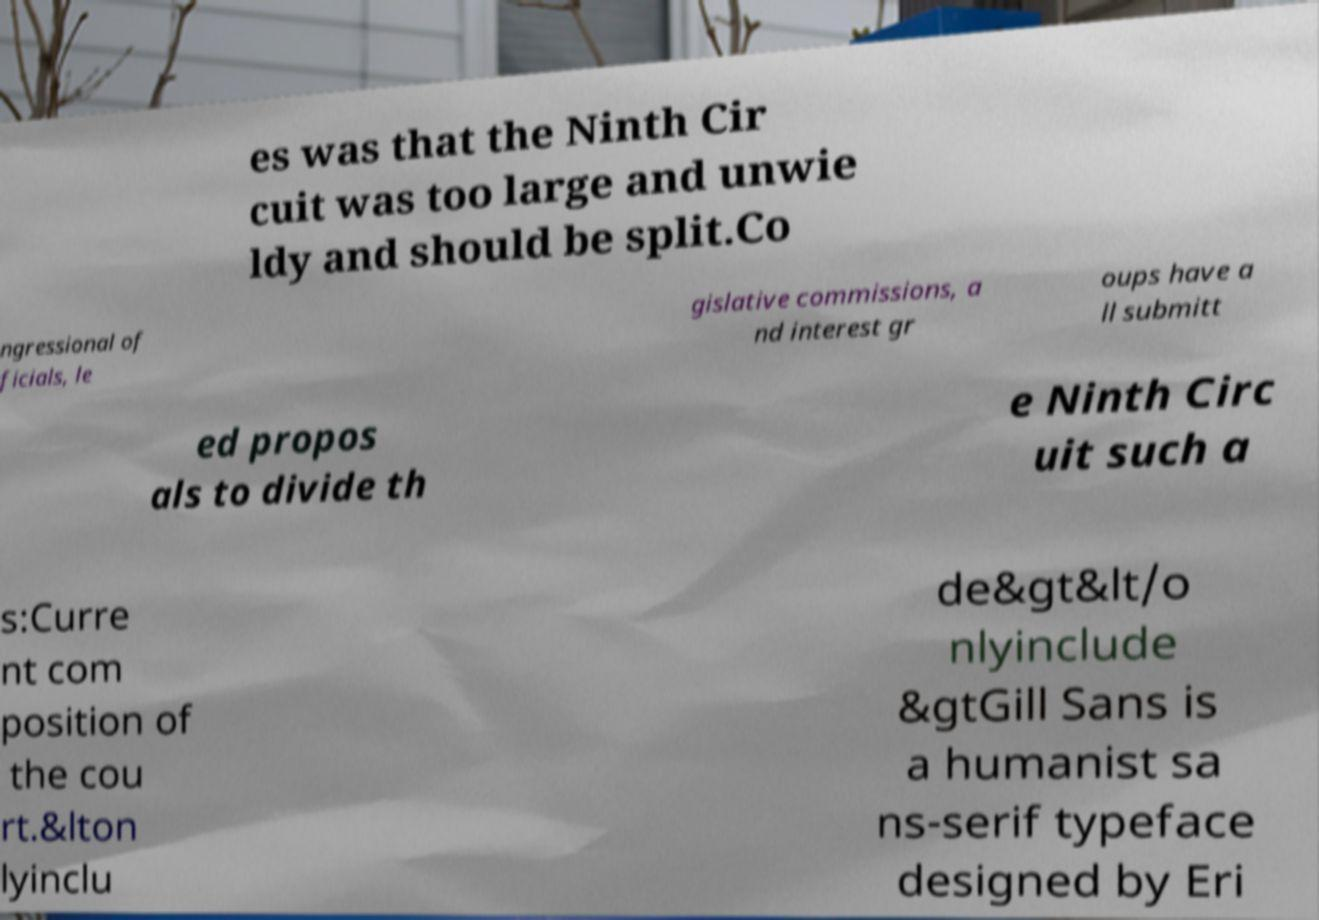I need the written content from this picture converted into text. Can you do that? es was that the Ninth Cir cuit was too large and unwie ldy and should be split.Co ngressional of ficials, le gislative commissions, a nd interest gr oups have a ll submitt ed propos als to divide th e Ninth Circ uit such a s:Curre nt com position of the cou rt.&lton lyinclu de&gt&lt/o nlyinclude &gtGill Sans is a humanist sa ns-serif typeface designed by Eri 